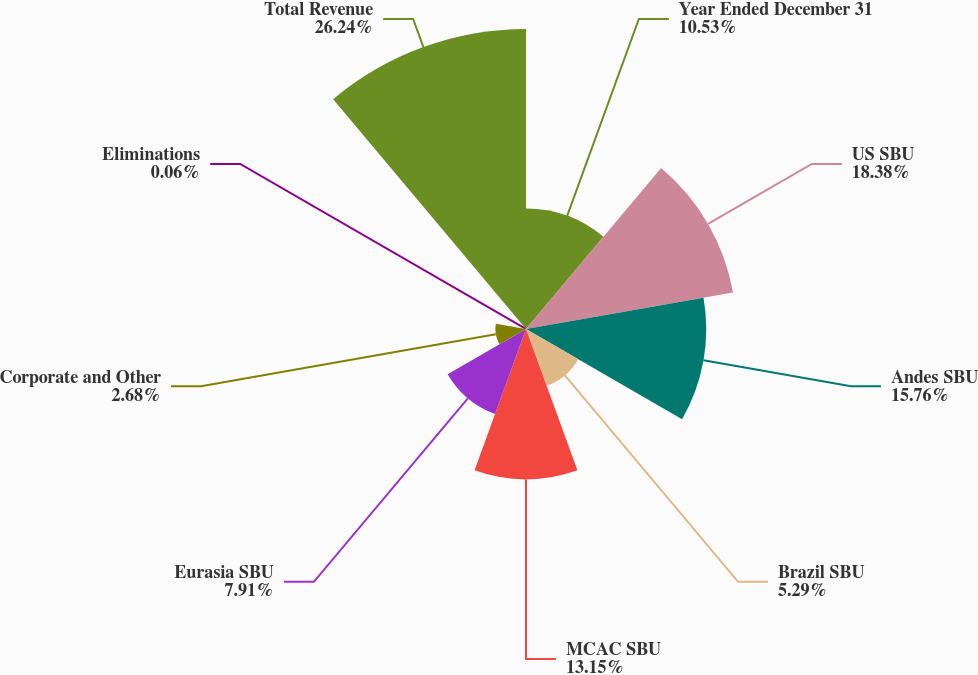<chart> <loc_0><loc_0><loc_500><loc_500><pie_chart><fcel>Year Ended December 31<fcel>US SBU<fcel>Andes SBU<fcel>Brazil SBU<fcel>MCAC SBU<fcel>Eurasia SBU<fcel>Corporate and Other<fcel>Eliminations<fcel>Total Revenue<nl><fcel>10.53%<fcel>18.38%<fcel>15.76%<fcel>5.29%<fcel>13.15%<fcel>7.91%<fcel>2.68%<fcel>0.06%<fcel>26.23%<nl></chart> 